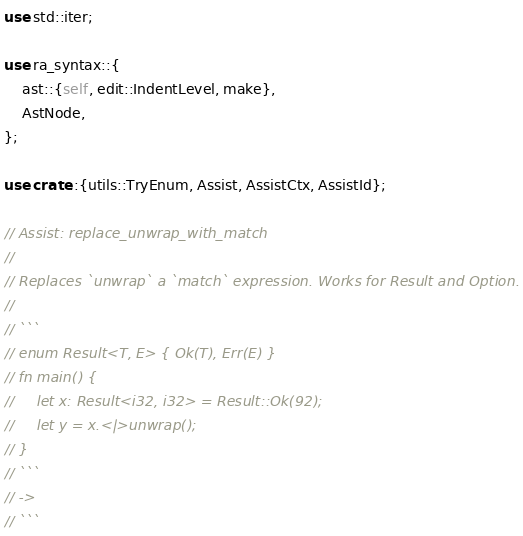Convert code to text. <code><loc_0><loc_0><loc_500><loc_500><_Rust_>use std::iter;

use ra_syntax::{
    ast::{self, edit::IndentLevel, make},
    AstNode,
};

use crate::{utils::TryEnum, Assist, AssistCtx, AssistId};

// Assist: replace_unwrap_with_match
//
// Replaces `unwrap` a `match` expression. Works for Result and Option.
//
// ```
// enum Result<T, E> { Ok(T), Err(E) }
// fn main() {
//     let x: Result<i32, i32> = Result::Ok(92);
//     let y = x.<|>unwrap();
// }
// ```
// ->
// ```</code> 